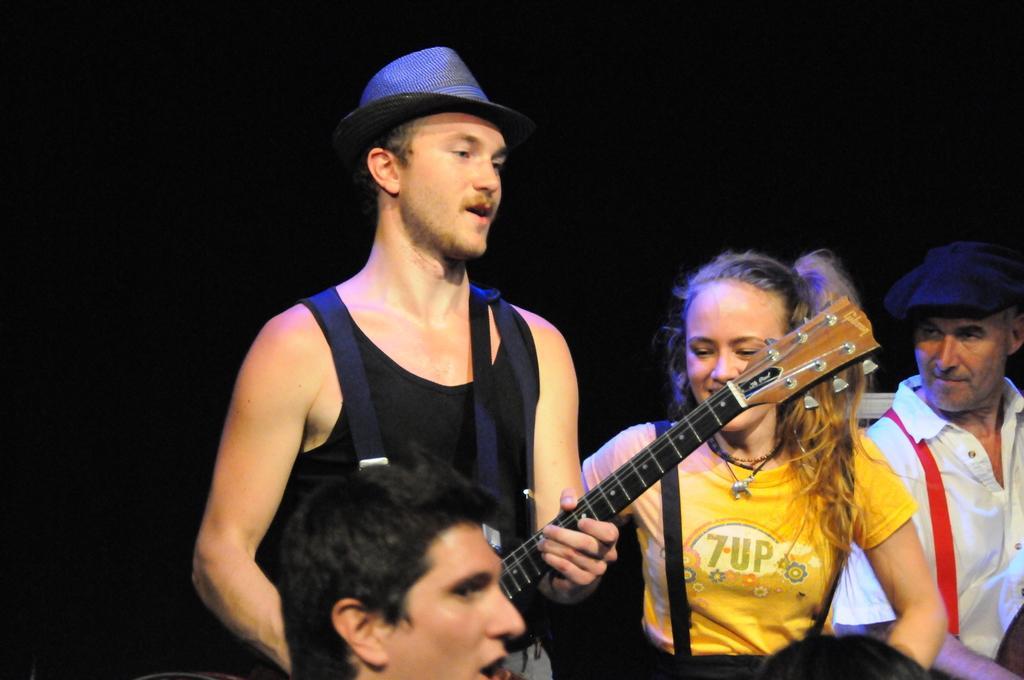Could you give a brief overview of what you see in this image? In this picture there is a person standing, singing and playing the guitar. There is a woman beside him, who is smiling and looking at the guitar, there is a person standing behind them and looking at the , In front there is another person who is singing and looking at the crowd. 